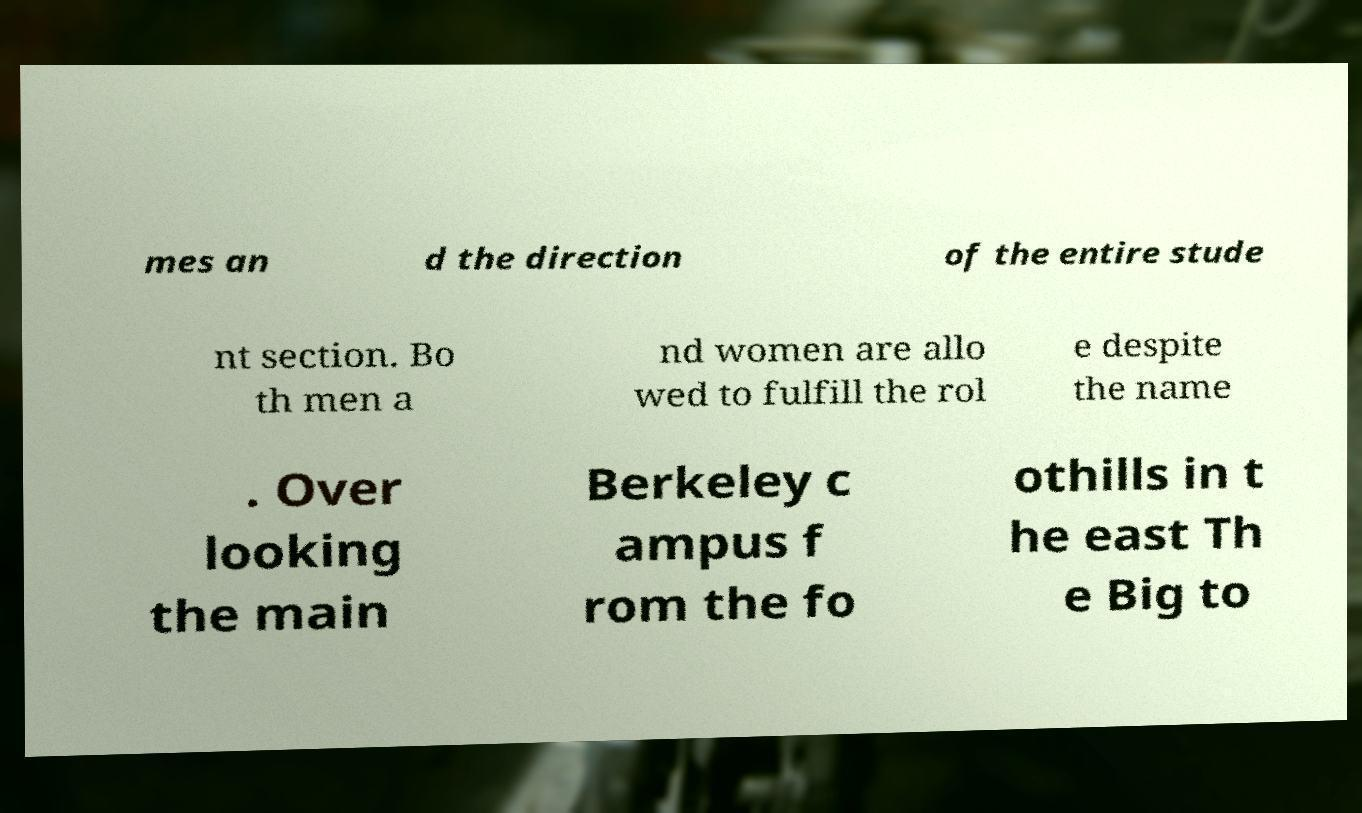Please read and relay the text visible in this image. What does it say? mes an d the direction of the entire stude nt section. Bo th men a nd women are allo wed to fulfill the rol e despite the name . Over looking the main Berkeley c ampus f rom the fo othills in t he east Th e Big to 